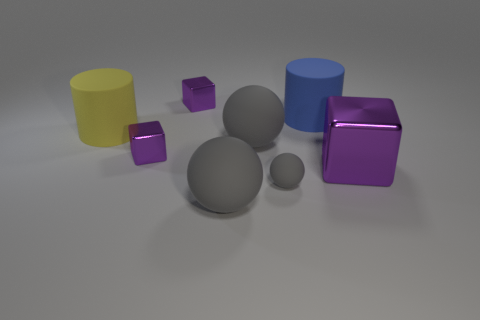How many large things are either cylinders or rubber things?
Your answer should be very brief. 4. Is the number of purple metallic blocks that are right of the big purple object the same as the number of big yellow cylinders to the left of the blue thing?
Your answer should be compact. No. How many other objects are the same color as the small matte sphere?
Give a very brief answer. 2. There is a large metal object; does it have the same color as the tiny block behind the yellow cylinder?
Keep it short and to the point. Yes. What number of gray things are tiny rubber things or rubber spheres?
Give a very brief answer. 3. Are there the same number of big matte things on the left side of the small rubber object and matte spheres?
Offer a terse response. Yes. There is another big matte thing that is the same shape as the big blue object; what color is it?
Give a very brief answer. Yellow. What number of blue objects have the same shape as the tiny gray rubber thing?
Provide a succinct answer. 0. What number of small yellow rubber blocks are there?
Make the answer very short. 0. Is there another yellow cylinder made of the same material as the yellow cylinder?
Your answer should be very brief. No. 